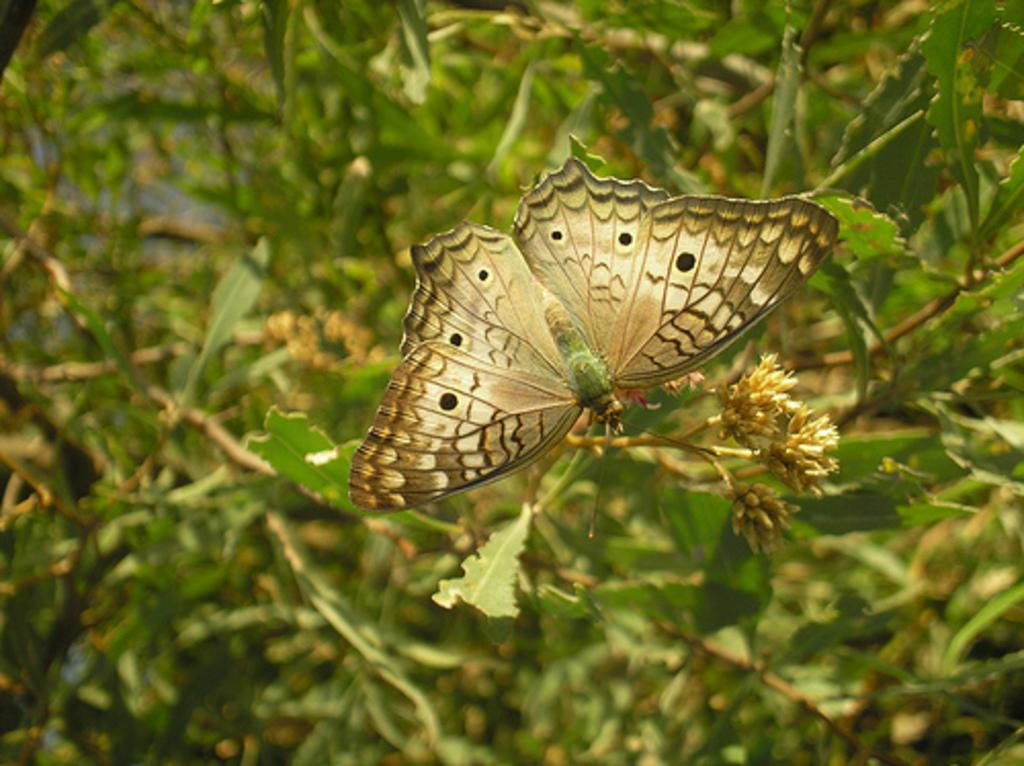What type of animal can be seen in the image? There is a butterfly in the image. What else is present in the image besides the butterfly? There is a plant in the image. Can you describe the background of the image? The background has a blurred view, and there are plants visible in the background. What type of plough is being used to cultivate the plants in the image? There is no plough present in the image; it features a butterfly and a plant. How many cows can be seen grazing on the plants in the image? There are no cows present in the image; it features a butterfly and a plant. 